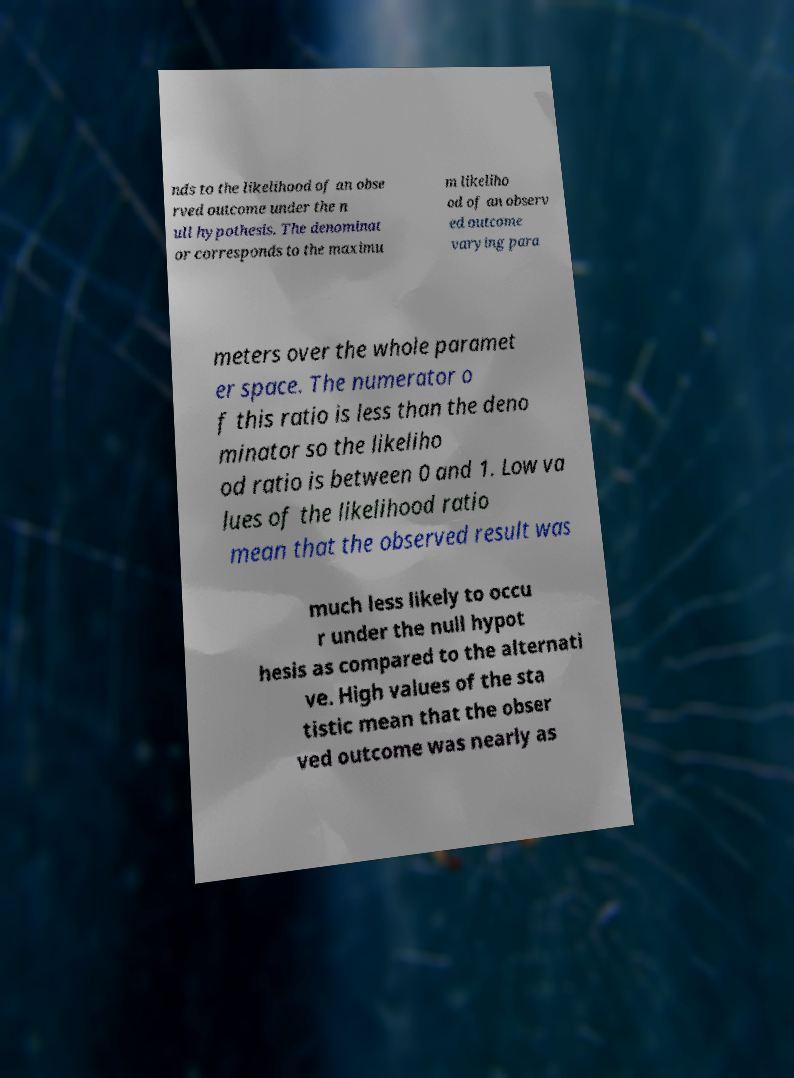There's text embedded in this image that I need extracted. Can you transcribe it verbatim? nds to the likelihood of an obse rved outcome under the n ull hypothesis. The denominat or corresponds to the maximu m likeliho od of an observ ed outcome varying para meters over the whole paramet er space. The numerator o f this ratio is less than the deno minator so the likeliho od ratio is between 0 and 1. Low va lues of the likelihood ratio mean that the observed result was much less likely to occu r under the null hypot hesis as compared to the alternati ve. High values of the sta tistic mean that the obser ved outcome was nearly as 